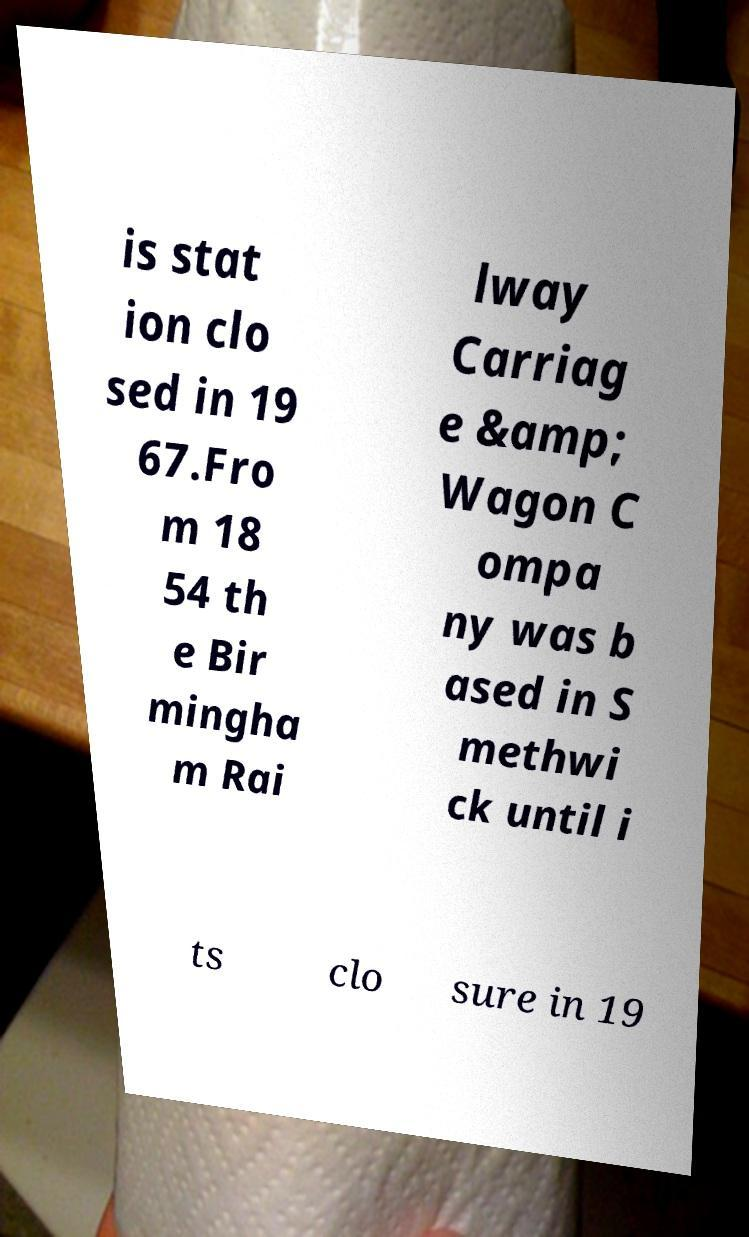There's text embedded in this image that I need extracted. Can you transcribe it verbatim? is stat ion clo sed in 19 67.Fro m 18 54 th e Bir mingha m Rai lway Carriag e &amp; Wagon C ompa ny was b ased in S methwi ck until i ts clo sure in 19 